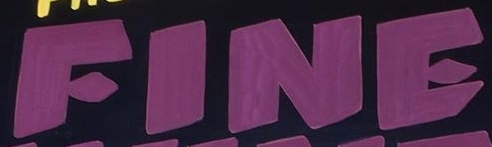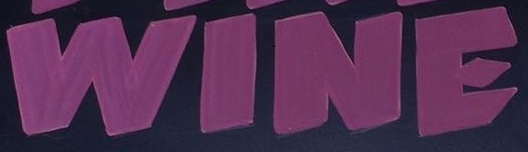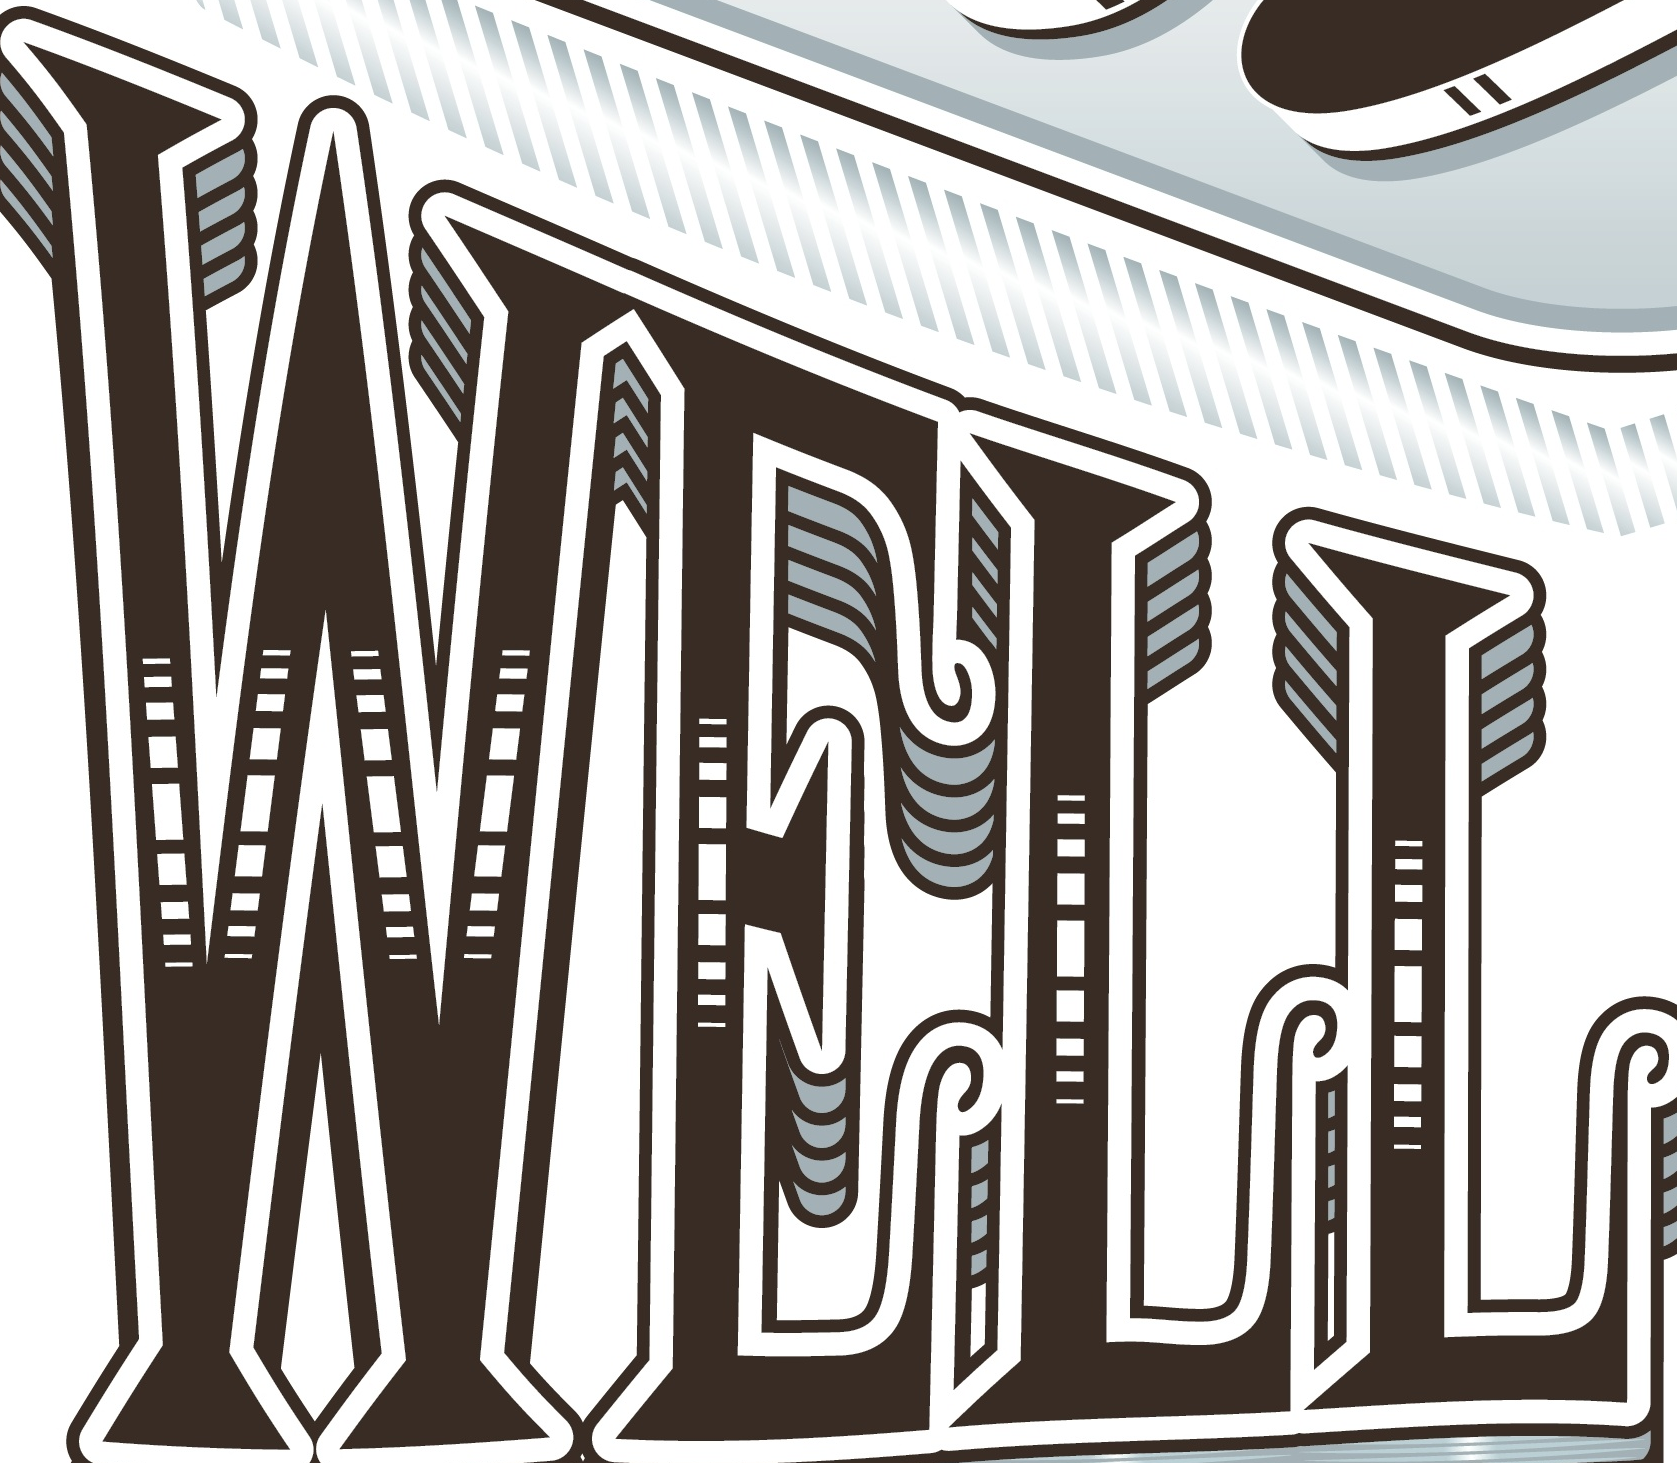Identify the words shown in these images in order, separated by a semicolon. FINE; WINE; WELL 